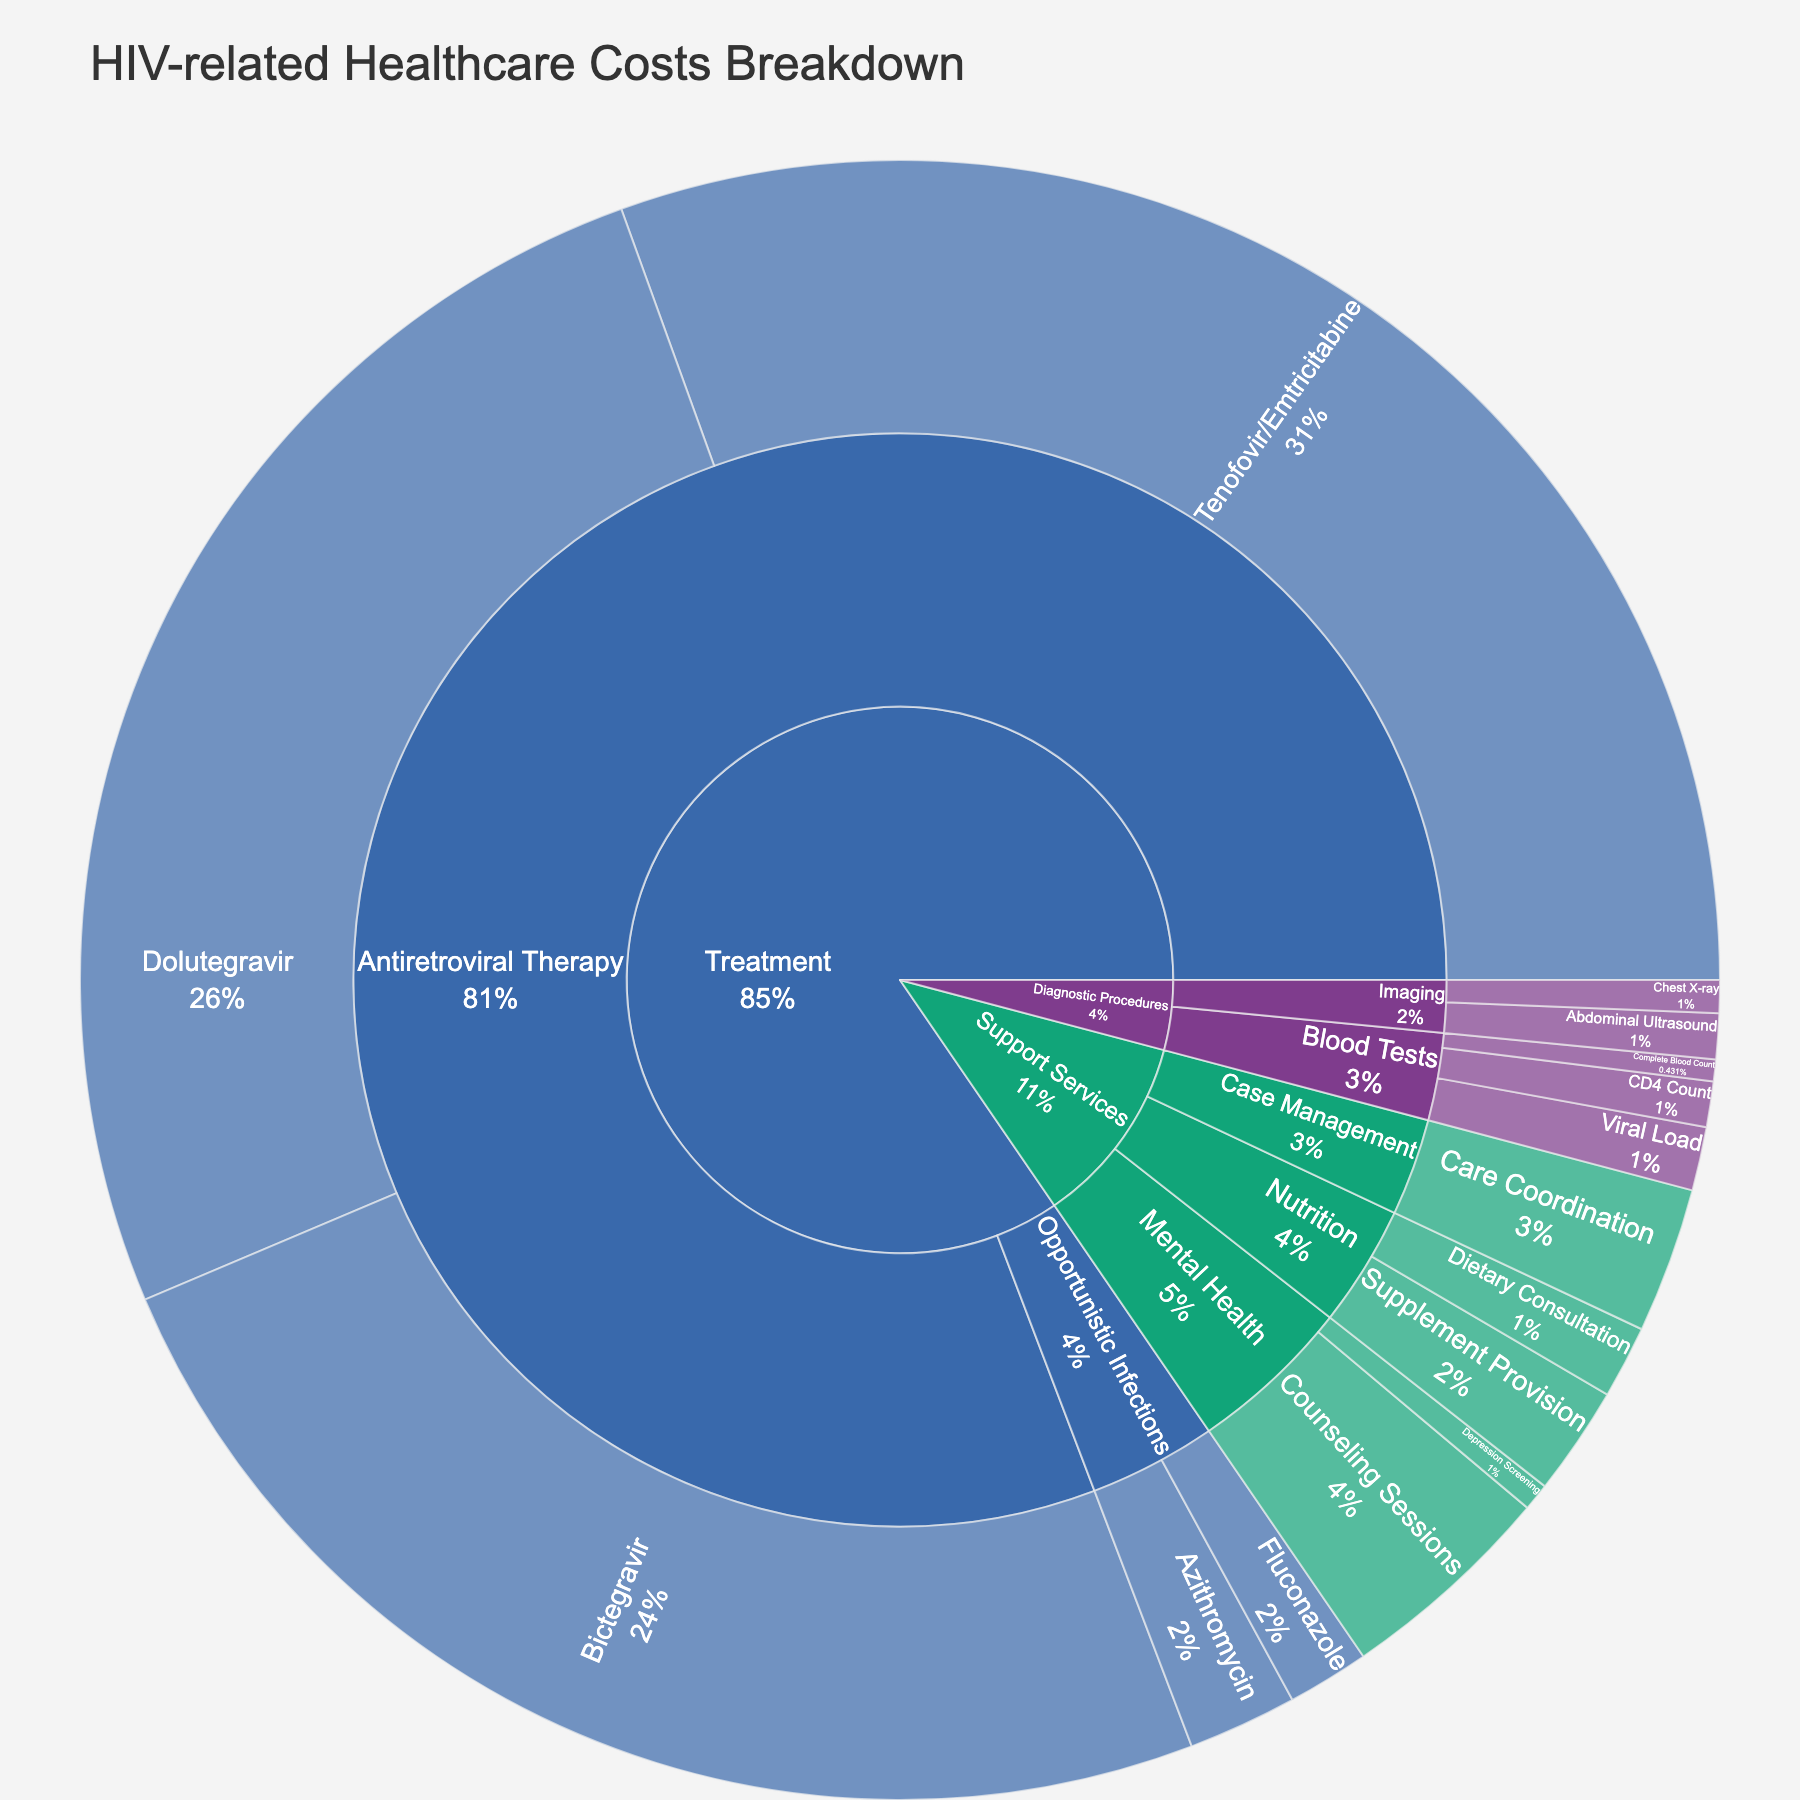What is the total cost of Tenofovir/Emtricitabine? The figure shows a section labeled "Tenofovir/Emtricitabine" under the "Antiretroviral Therapy" subcategory of the "Treatment" category. The specified cost value is illustrated within that section.
Answer: $8,500 What percentage of the total cost is due to Antiretroviral Therapy? Identify the part of the sunburst plot labeled "Antiretroviral Therapy" and use the percentage information displayed for this sector.
Answer: Approximately 83.5% Which treatment type has the lowest cost? The plot segments for treatment types like Antiretroviral Therapy and Opportunistic Infections, and compare their cost values. Opportunistic Infections shows values lower than Antiretroviral Therapy.
Answer: Opportunistic Infections How much more expensive is Tenofovir/Emtricitabine compared to Fluconazole? Locate and subtract the cost value of Fluconazole from Tenofovir/Emtricitabine presented in the plot. Tenofovir/Emtricitabine costs $8,500 and Fluconazole costs $450, so $8,500 - $450.
Answer: $8,050 What is the combined cost of diagnostic procedures (Blood Tests and Imaging)? Sum the cost values presented within the "Blood Tests" and "Imaging" segments. Blood Tests: $250+$350+$120=$720, Imaging: $180+$250=$430, Total = $720 + $430.
Answer: $1,150 Among the support services, which one incurs the highest cost? Compare the different cost values within the "Support Services" category. Counseling Sessions under Mental Health shows the highest value at $1,200.
Answer: Counseling Sessions Is the cost of Dietary Consultation lower than both Care Coordination and Supplement Provision? Check the costs for Dietary Consultation ($400) relative to Care Coordination ($800) and Supplement Provision ($600). Indeed, $400 is lower than both $800 and $600.
Answer: Yes What is the overall cost for Mental Health services? Add the costs of "Counseling Sessions" and "Depression Screening" under the Mental Health subcategory: $1,200 + $150.
Answer: $1,350 Which item within Diagnostic Procedures has the highest cost? Examine each item under "Diagnostic Procedures" and determine the one with the highest cost. The "Viral Load" test has the highest value at $350.
Answer: Viral Load How do the costs of Chest X-ray and Abdominal Ultrasound compare? Compare the cost values directly within the Imaging category. The values are $180 for Chest X-ray and $250 for Abdominal Ultrasound.
Answer: Abdominal Ultrasound is higher 